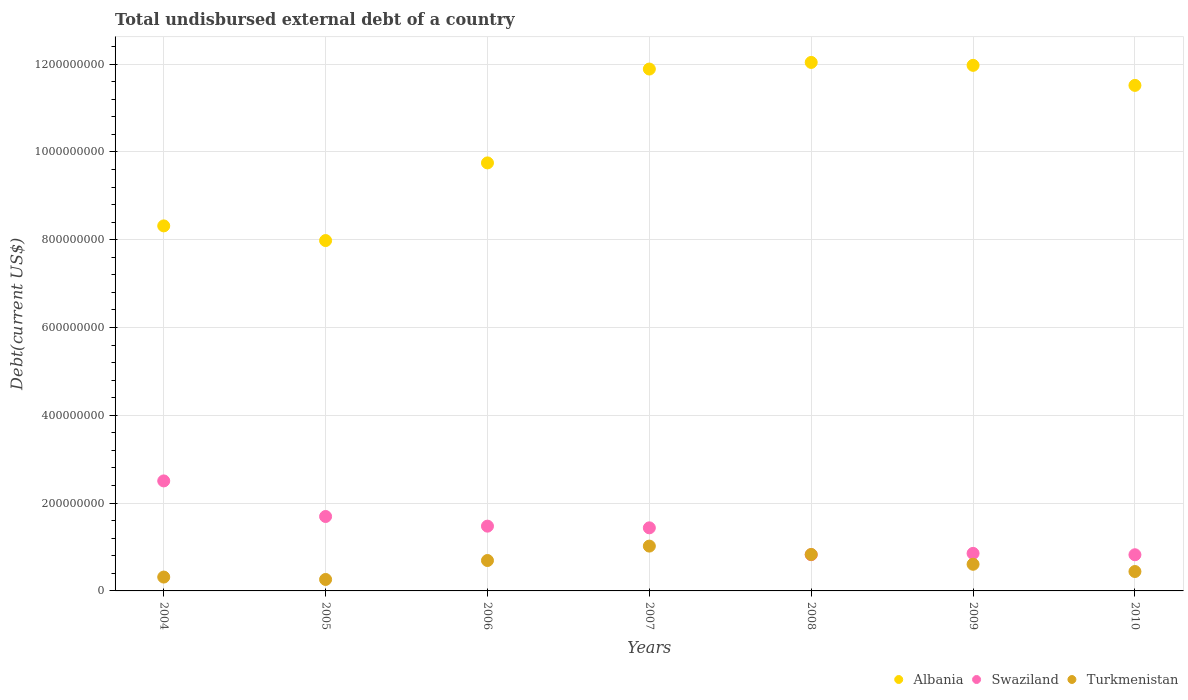How many different coloured dotlines are there?
Your response must be concise. 3. What is the total undisbursed external debt in Turkmenistan in 2008?
Your answer should be very brief. 8.30e+07. Across all years, what is the maximum total undisbursed external debt in Swaziland?
Ensure brevity in your answer.  2.51e+08. Across all years, what is the minimum total undisbursed external debt in Swaziland?
Your response must be concise. 8.24e+07. What is the total total undisbursed external debt in Albania in the graph?
Ensure brevity in your answer.  7.35e+09. What is the difference between the total undisbursed external debt in Swaziland in 2005 and that in 2007?
Make the answer very short. 2.58e+07. What is the difference between the total undisbursed external debt in Albania in 2009 and the total undisbursed external debt in Swaziland in 2010?
Offer a very short reply. 1.11e+09. What is the average total undisbursed external debt in Swaziland per year?
Your response must be concise. 1.37e+08. In the year 2009, what is the difference between the total undisbursed external debt in Albania and total undisbursed external debt in Turkmenistan?
Provide a succinct answer. 1.14e+09. What is the ratio of the total undisbursed external debt in Turkmenistan in 2008 to that in 2010?
Your response must be concise. 1.88. Is the total undisbursed external debt in Turkmenistan in 2007 less than that in 2008?
Your response must be concise. No. What is the difference between the highest and the second highest total undisbursed external debt in Turkmenistan?
Offer a terse response. 1.91e+07. What is the difference between the highest and the lowest total undisbursed external debt in Albania?
Your response must be concise. 4.06e+08. Is it the case that in every year, the sum of the total undisbursed external debt in Turkmenistan and total undisbursed external debt in Swaziland  is greater than the total undisbursed external debt in Albania?
Offer a terse response. No. Is the total undisbursed external debt in Albania strictly greater than the total undisbursed external debt in Turkmenistan over the years?
Offer a terse response. Yes. How many dotlines are there?
Give a very brief answer. 3. What is the difference between two consecutive major ticks on the Y-axis?
Offer a very short reply. 2.00e+08. Does the graph contain any zero values?
Your answer should be very brief. No. Does the graph contain grids?
Offer a terse response. Yes. Where does the legend appear in the graph?
Give a very brief answer. Bottom right. What is the title of the graph?
Give a very brief answer. Total undisbursed external debt of a country. Does "Uzbekistan" appear as one of the legend labels in the graph?
Give a very brief answer. No. What is the label or title of the X-axis?
Your answer should be compact. Years. What is the label or title of the Y-axis?
Your response must be concise. Debt(current US$). What is the Debt(current US$) of Albania in 2004?
Make the answer very short. 8.31e+08. What is the Debt(current US$) in Swaziland in 2004?
Give a very brief answer. 2.51e+08. What is the Debt(current US$) of Turkmenistan in 2004?
Your answer should be very brief. 3.16e+07. What is the Debt(current US$) in Albania in 2005?
Make the answer very short. 7.98e+08. What is the Debt(current US$) in Swaziland in 2005?
Give a very brief answer. 1.70e+08. What is the Debt(current US$) of Turkmenistan in 2005?
Offer a very short reply. 2.61e+07. What is the Debt(current US$) in Albania in 2006?
Offer a very short reply. 9.75e+08. What is the Debt(current US$) of Swaziland in 2006?
Give a very brief answer. 1.48e+08. What is the Debt(current US$) of Turkmenistan in 2006?
Make the answer very short. 6.93e+07. What is the Debt(current US$) in Albania in 2007?
Offer a terse response. 1.19e+09. What is the Debt(current US$) of Swaziland in 2007?
Your answer should be very brief. 1.44e+08. What is the Debt(current US$) of Turkmenistan in 2007?
Keep it short and to the point. 1.02e+08. What is the Debt(current US$) in Albania in 2008?
Offer a terse response. 1.20e+09. What is the Debt(current US$) in Swaziland in 2008?
Provide a succinct answer. 8.25e+07. What is the Debt(current US$) of Turkmenistan in 2008?
Provide a succinct answer. 8.30e+07. What is the Debt(current US$) of Albania in 2009?
Offer a terse response. 1.20e+09. What is the Debt(current US$) of Swaziland in 2009?
Your answer should be very brief. 8.55e+07. What is the Debt(current US$) in Turkmenistan in 2009?
Provide a succinct answer. 6.07e+07. What is the Debt(current US$) in Albania in 2010?
Ensure brevity in your answer.  1.15e+09. What is the Debt(current US$) of Swaziland in 2010?
Offer a very short reply. 8.24e+07. What is the Debt(current US$) of Turkmenistan in 2010?
Your answer should be very brief. 4.42e+07. Across all years, what is the maximum Debt(current US$) of Albania?
Your response must be concise. 1.20e+09. Across all years, what is the maximum Debt(current US$) in Swaziland?
Offer a terse response. 2.51e+08. Across all years, what is the maximum Debt(current US$) in Turkmenistan?
Offer a very short reply. 1.02e+08. Across all years, what is the minimum Debt(current US$) of Albania?
Provide a succinct answer. 7.98e+08. Across all years, what is the minimum Debt(current US$) in Swaziland?
Ensure brevity in your answer.  8.24e+07. Across all years, what is the minimum Debt(current US$) of Turkmenistan?
Offer a terse response. 2.61e+07. What is the total Debt(current US$) in Albania in the graph?
Your response must be concise. 7.35e+09. What is the total Debt(current US$) in Swaziland in the graph?
Offer a very short reply. 9.62e+08. What is the total Debt(current US$) in Turkmenistan in the graph?
Your answer should be very brief. 4.17e+08. What is the difference between the Debt(current US$) in Albania in 2004 and that in 2005?
Keep it short and to the point. 3.34e+07. What is the difference between the Debt(current US$) in Swaziland in 2004 and that in 2005?
Keep it short and to the point. 8.10e+07. What is the difference between the Debt(current US$) of Turkmenistan in 2004 and that in 2005?
Give a very brief answer. 5.43e+06. What is the difference between the Debt(current US$) in Albania in 2004 and that in 2006?
Ensure brevity in your answer.  -1.43e+08. What is the difference between the Debt(current US$) of Swaziland in 2004 and that in 2006?
Your answer should be very brief. 1.03e+08. What is the difference between the Debt(current US$) of Turkmenistan in 2004 and that in 2006?
Provide a short and direct response. -3.77e+07. What is the difference between the Debt(current US$) of Albania in 2004 and that in 2007?
Offer a terse response. -3.57e+08. What is the difference between the Debt(current US$) of Swaziland in 2004 and that in 2007?
Make the answer very short. 1.07e+08. What is the difference between the Debt(current US$) of Turkmenistan in 2004 and that in 2007?
Offer a very short reply. -7.05e+07. What is the difference between the Debt(current US$) of Albania in 2004 and that in 2008?
Offer a terse response. -3.72e+08. What is the difference between the Debt(current US$) of Swaziland in 2004 and that in 2008?
Your answer should be very brief. 1.68e+08. What is the difference between the Debt(current US$) of Turkmenistan in 2004 and that in 2008?
Your response must be concise. -5.15e+07. What is the difference between the Debt(current US$) of Albania in 2004 and that in 2009?
Provide a short and direct response. -3.66e+08. What is the difference between the Debt(current US$) in Swaziland in 2004 and that in 2009?
Your response must be concise. 1.65e+08. What is the difference between the Debt(current US$) of Turkmenistan in 2004 and that in 2009?
Give a very brief answer. -2.91e+07. What is the difference between the Debt(current US$) of Albania in 2004 and that in 2010?
Offer a terse response. -3.20e+08. What is the difference between the Debt(current US$) in Swaziland in 2004 and that in 2010?
Your answer should be compact. 1.68e+08. What is the difference between the Debt(current US$) in Turkmenistan in 2004 and that in 2010?
Make the answer very short. -1.27e+07. What is the difference between the Debt(current US$) in Albania in 2005 and that in 2006?
Provide a succinct answer. -1.77e+08. What is the difference between the Debt(current US$) in Swaziland in 2005 and that in 2006?
Ensure brevity in your answer.  2.20e+07. What is the difference between the Debt(current US$) of Turkmenistan in 2005 and that in 2006?
Give a very brief answer. -4.32e+07. What is the difference between the Debt(current US$) of Albania in 2005 and that in 2007?
Give a very brief answer. -3.91e+08. What is the difference between the Debt(current US$) of Swaziland in 2005 and that in 2007?
Keep it short and to the point. 2.58e+07. What is the difference between the Debt(current US$) of Turkmenistan in 2005 and that in 2007?
Make the answer very short. -7.60e+07. What is the difference between the Debt(current US$) of Albania in 2005 and that in 2008?
Offer a terse response. -4.06e+08. What is the difference between the Debt(current US$) of Swaziland in 2005 and that in 2008?
Your answer should be very brief. 8.70e+07. What is the difference between the Debt(current US$) in Turkmenistan in 2005 and that in 2008?
Provide a short and direct response. -5.69e+07. What is the difference between the Debt(current US$) of Albania in 2005 and that in 2009?
Offer a very short reply. -3.99e+08. What is the difference between the Debt(current US$) of Swaziland in 2005 and that in 2009?
Keep it short and to the point. 8.40e+07. What is the difference between the Debt(current US$) of Turkmenistan in 2005 and that in 2009?
Your answer should be very brief. -3.46e+07. What is the difference between the Debt(current US$) in Albania in 2005 and that in 2010?
Your answer should be compact. -3.53e+08. What is the difference between the Debt(current US$) in Swaziland in 2005 and that in 2010?
Provide a short and direct response. 8.72e+07. What is the difference between the Debt(current US$) in Turkmenistan in 2005 and that in 2010?
Your answer should be very brief. -1.81e+07. What is the difference between the Debt(current US$) in Albania in 2006 and that in 2007?
Keep it short and to the point. -2.14e+08. What is the difference between the Debt(current US$) in Swaziland in 2006 and that in 2007?
Ensure brevity in your answer.  3.86e+06. What is the difference between the Debt(current US$) in Turkmenistan in 2006 and that in 2007?
Your response must be concise. -3.28e+07. What is the difference between the Debt(current US$) of Albania in 2006 and that in 2008?
Ensure brevity in your answer.  -2.29e+08. What is the difference between the Debt(current US$) of Swaziland in 2006 and that in 2008?
Provide a succinct answer. 6.51e+07. What is the difference between the Debt(current US$) of Turkmenistan in 2006 and that in 2008?
Keep it short and to the point. -1.38e+07. What is the difference between the Debt(current US$) in Albania in 2006 and that in 2009?
Your answer should be very brief. -2.22e+08. What is the difference between the Debt(current US$) in Swaziland in 2006 and that in 2009?
Your response must be concise. 6.20e+07. What is the difference between the Debt(current US$) of Turkmenistan in 2006 and that in 2009?
Give a very brief answer. 8.58e+06. What is the difference between the Debt(current US$) in Albania in 2006 and that in 2010?
Ensure brevity in your answer.  -1.77e+08. What is the difference between the Debt(current US$) in Swaziland in 2006 and that in 2010?
Your response must be concise. 6.52e+07. What is the difference between the Debt(current US$) in Turkmenistan in 2006 and that in 2010?
Provide a short and direct response. 2.51e+07. What is the difference between the Debt(current US$) of Albania in 2007 and that in 2008?
Give a very brief answer. -1.51e+07. What is the difference between the Debt(current US$) in Swaziland in 2007 and that in 2008?
Offer a very short reply. 6.12e+07. What is the difference between the Debt(current US$) in Turkmenistan in 2007 and that in 2008?
Offer a terse response. 1.91e+07. What is the difference between the Debt(current US$) of Albania in 2007 and that in 2009?
Your response must be concise. -8.43e+06. What is the difference between the Debt(current US$) in Swaziland in 2007 and that in 2009?
Your response must be concise. 5.82e+07. What is the difference between the Debt(current US$) in Turkmenistan in 2007 and that in 2009?
Provide a short and direct response. 4.14e+07. What is the difference between the Debt(current US$) of Albania in 2007 and that in 2010?
Keep it short and to the point. 3.72e+07. What is the difference between the Debt(current US$) of Swaziland in 2007 and that in 2010?
Provide a short and direct response. 6.13e+07. What is the difference between the Debt(current US$) in Turkmenistan in 2007 and that in 2010?
Ensure brevity in your answer.  5.79e+07. What is the difference between the Debt(current US$) in Albania in 2008 and that in 2009?
Your answer should be very brief. 6.65e+06. What is the difference between the Debt(current US$) of Swaziland in 2008 and that in 2009?
Offer a very short reply. -3.02e+06. What is the difference between the Debt(current US$) of Turkmenistan in 2008 and that in 2009?
Provide a short and direct response. 2.23e+07. What is the difference between the Debt(current US$) of Albania in 2008 and that in 2010?
Your answer should be very brief. 5.23e+07. What is the difference between the Debt(current US$) in Swaziland in 2008 and that in 2010?
Keep it short and to the point. 1.10e+05. What is the difference between the Debt(current US$) of Turkmenistan in 2008 and that in 2010?
Your answer should be very brief. 3.88e+07. What is the difference between the Debt(current US$) of Albania in 2009 and that in 2010?
Give a very brief answer. 4.56e+07. What is the difference between the Debt(current US$) of Swaziland in 2009 and that in 2010?
Ensure brevity in your answer.  3.13e+06. What is the difference between the Debt(current US$) of Turkmenistan in 2009 and that in 2010?
Give a very brief answer. 1.65e+07. What is the difference between the Debt(current US$) of Albania in 2004 and the Debt(current US$) of Swaziland in 2005?
Make the answer very short. 6.62e+08. What is the difference between the Debt(current US$) in Albania in 2004 and the Debt(current US$) in Turkmenistan in 2005?
Offer a very short reply. 8.05e+08. What is the difference between the Debt(current US$) of Swaziland in 2004 and the Debt(current US$) of Turkmenistan in 2005?
Keep it short and to the point. 2.24e+08. What is the difference between the Debt(current US$) of Albania in 2004 and the Debt(current US$) of Swaziland in 2006?
Make the answer very short. 6.84e+08. What is the difference between the Debt(current US$) of Albania in 2004 and the Debt(current US$) of Turkmenistan in 2006?
Offer a terse response. 7.62e+08. What is the difference between the Debt(current US$) in Swaziland in 2004 and the Debt(current US$) in Turkmenistan in 2006?
Your answer should be very brief. 1.81e+08. What is the difference between the Debt(current US$) in Albania in 2004 and the Debt(current US$) in Swaziland in 2007?
Keep it short and to the point. 6.88e+08. What is the difference between the Debt(current US$) of Albania in 2004 and the Debt(current US$) of Turkmenistan in 2007?
Ensure brevity in your answer.  7.29e+08. What is the difference between the Debt(current US$) of Swaziland in 2004 and the Debt(current US$) of Turkmenistan in 2007?
Keep it short and to the point. 1.48e+08. What is the difference between the Debt(current US$) of Albania in 2004 and the Debt(current US$) of Swaziland in 2008?
Provide a short and direct response. 7.49e+08. What is the difference between the Debt(current US$) in Albania in 2004 and the Debt(current US$) in Turkmenistan in 2008?
Make the answer very short. 7.48e+08. What is the difference between the Debt(current US$) in Swaziland in 2004 and the Debt(current US$) in Turkmenistan in 2008?
Provide a succinct answer. 1.68e+08. What is the difference between the Debt(current US$) of Albania in 2004 and the Debt(current US$) of Swaziland in 2009?
Provide a short and direct response. 7.46e+08. What is the difference between the Debt(current US$) in Albania in 2004 and the Debt(current US$) in Turkmenistan in 2009?
Your response must be concise. 7.71e+08. What is the difference between the Debt(current US$) in Swaziland in 2004 and the Debt(current US$) in Turkmenistan in 2009?
Offer a terse response. 1.90e+08. What is the difference between the Debt(current US$) in Albania in 2004 and the Debt(current US$) in Swaziland in 2010?
Make the answer very short. 7.49e+08. What is the difference between the Debt(current US$) of Albania in 2004 and the Debt(current US$) of Turkmenistan in 2010?
Keep it short and to the point. 7.87e+08. What is the difference between the Debt(current US$) of Swaziland in 2004 and the Debt(current US$) of Turkmenistan in 2010?
Offer a very short reply. 2.06e+08. What is the difference between the Debt(current US$) in Albania in 2005 and the Debt(current US$) in Swaziland in 2006?
Your answer should be compact. 6.51e+08. What is the difference between the Debt(current US$) of Albania in 2005 and the Debt(current US$) of Turkmenistan in 2006?
Give a very brief answer. 7.29e+08. What is the difference between the Debt(current US$) of Swaziland in 2005 and the Debt(current US$) of Turkmenistan in 2006?
Your answer should be very brief. 1.00e+08. What is the difference between the Debt(current US$) in Albania in 2005 and the Debt(current US$) in Swaziland in 2007?
Ensure brevity in your answer.  6.54e+08. What is the difference between the Debt(current US$) of Albania in 2005 and the Debt(current US$) of Turkmenistan in 2007?
Keep it short and to the point. 6.96e+08. What is the difference between the Debt(current US$) of Swaziland in 2005 and the Debt(current US$) of Turkmenistan in 2007?
Your response must be concise. 6.74e+07. What is the difference between the Debt(current US$) in Albania in 2005 and the Debt(current US$) in Swaziland in 2008?
Your response must be concise. 7.16e+08. What is the difference between the Debt(current US$) in Albania in 2005 and the Debt(current US$) in Turkmenistan in 2008?
Your response must be concise. 7.15e+08. What is the difference between the Debt(current US$) of Swaziland in 2005 and the Debt(current US$) of Turkmenistan in 2008?
Give a very brief answer. 8.65e+07. What is the difference between the Debt(current US$) in Albania in 2005 and the Debt(current US$) in Swaziland in 2009?
Your answer should be very brief. 7.13e+08. What is the difference between the Debt(current US$) of Albania in 2005 and the Debt(current US$) of Turkmenistan in 2009?
Offer a terse response. 7.37e+08. What is the difference between the Debt(current US$) in Swaziland in 2005 and the Debt(current US$) in Turkmenistan in 2009?
Make the answer very short. 1.09e+08. What is the difference between the Debt(current US$) in Albania in 2005 and the Debt(current US$) in Swaziland in 2010?
Keep it short and to the point. 7.16e+08. What is the difference between the Debt(current US$) in Albania in 2005 and the Debt(current US$) in Turkmenistan in 2010?
Offer a very short reply. 7.54e+08. What is the difference between the Debt(current US$) of Swaziland in 2005 and the Debt(current US$) of Turkmenistan in 2010?
Your response must be concise. 1.25e+08. What is the difference between the Debt(current US$) in Albania in 2006 and the Debt(current US$) in Swaziland in 2007?
Your answer should be very brief. 8.31e+08. What is the difference between the Debt(current US$) in Albania in 2006 and the Debt(current US$) in Turkmenistan in 2007?
Your answer should be very brief. 8.73e+08. What is the difference between the Debt(current US$) in Swaziland in 2006 and the Debt(current US$) in Turkmenistan in 2007?
Your answer should be very brief. 4.54e+07. What is the difference between the Debt(current US$) of Albania in 2006 and the Debt(current US$) of Swaziland in 2008?
Make the answer very short. 8.92e+08. What is the difference between the Debt(current US$) of Albania in 2006 and the Debt(current US$) of Turkmenistan in 2008?
Your response must be concise. 8.92e+08. What is the difference between the Debt(current US$) of Swaziland in 2006 and the Debt(current US$) of Turkmenistan in 2008?
Your answer should be very brief. 6.45e+07. What is the difference between the Debt(current US$) of Albania in 2006 and the Debt(current US$) of Swaziland in 2009?
Your response must be concise. 8.89e+08. What is the difference between the Debt(current US$) in Albania in 2006 and the Debt(current US$) in Turkmenistan in 2009?
Offer a very short reply. 9.14e+08. What is the difference between the Debt(current US$) in Swaziland in 2006 and the Debt(current US$) in Turkmenistan in 2009?
Offer a terse response. 8.69e+07. What is the difference between the Debt(current US$) in Albania in 2006 and the Debt(current US$) in Swaziland in 2010?
Your answer should be very brief. 8.93e+08. What is the difference between the Debt(current US$) of Albania in 2006 and the Debt(current US$) of Turkmenistan in 2010?
Give a very brief answer. 9.31e+08. What is the difference between the Debt(current US$) in Swaziland in 2006 and the Debt(current US$) in Turkmenistan in 2010?
Offer a terse response. 1.03e+08. What is the difference between the Debt(current US$) of Albania in 2007 and the Debt(current US$) of Swaziland in 2008?
Your response must be concise. 1.11e+09. What is the difference between the Debt(current US$) in Albania in 2007 and the Debt(current US$) in Turkmenistan in 2008?
Provide a succinct answer. 1.11e+09. What is the difference between the Debt(current US$) of Swaziland in 2007 and the Debt(current US$) of Turkmenistan in 2008?
Provide a short and direct response. 6.07e+07. What is the difference between the Debt(current US$) in Albania in 2007 and the Debt(current US$) in Swaziland in 2009?
Keep it short and to the point. 1.10e+09. What is the difference between the Debt(current US$) of Albania in 2007 and the Debt(current US$) of Turkmenistan in 2009?
Your answer should be compact. 1.13e+09. What is the difference between the Debt(current US$) in Swaziland in 2007 and the Debt(current US$) in Turkmenistan in 2009?
Offer a very short reply. 8.30e+07. What is the difference between the Debt(current US$) in Albania in 2007 and the Debt(current US$) in Swaziland in 2010?
Provide a succinct answer. 1.11e+09. What is the difference between the Debt(current US$) of Albania in 2007 and the Debt(current US$) of Turkmenistan in 2010?
Your answer should be compact. 1.14e+09. What is the difference between the Debt(current US$) of Swaziland in 2007 and the Debt(current US$) of Turkmenistan in 2010?
Your response must be concise. 9.95e+07. What is the difference between the Debt(current US$) of Albania in 2008 and the Debt(current US$) of Swaziland in 2009?
Your answer should be very brief. 1.12e+09. What is the difference between the Debt(current US$) of Albania in 2008 and the Debt(current US$) of Turkmenistan in 2009?
Provide a succinct answer. 1.14e+09. What is the difference between the Debt(current US$) of Swaziland in 2008 and the Debt(current US$) of Turkmenistan in 2009?
Your response must be concise. 2.18e+07. What is the difference between the Debt(current US$) of Albania in 2008 and the Debt(current US$) of Swaziland in 2010?
Your response must be concise. 1.12e+09. What is the difference between the Debt(current US$) in Albania in 2008 and the Debt(current US$) in Turkmenistan in 2010?
Ensure brevity in your answer.  1.16e+09. What is the difference between the Debt(current US$) in Swaziland in 2008 and the Debt(current US$) in Turkmenistan in 2010?
Your answer should be very brief. 3.83e+07. What is the difference between the Debt(current US$) of Albania in 2009 and the Debt(current US$) of Swaziland in 2010?
Offer a terse response. 1.11e+09. What is the difference between the Debt(current US$) of Albania in 2009 and the Debt(current US$) of Turkmenistan in 2010?
Make the answer very short. 1.15e+09. What is the difference between the Debt(current US$) of Swaziland in 2009 and the Debt(current US$) of Turkmenistan in 2010?
Your answer should be very brief. 4.13e+07. What is the average Debt(current US$) in Albania per year?
Make the answer very short. 1.05e+09. What is the average Debt(current US$) in Swaziland per year?
Your response must be concise. 1.37e+08. What is the average Debt(current US$) of Turkmenistan per year?
Your answer should be compact. 5.96e+07. In the year 2004, what is the difference between the Debt(current US$) in Albania and Debt(current US$) in Swaziland?
Your response must be concise. 5.81e+08. In the year 2004, what is the difference between the Debt(current US$) of Albania and Debt(current US$) of Turkmenistan?
Give a very brief answer. 8.00e+08. In the year 2004, what is the difference between the Debt(current US$) of Swaziland and Debt(current US$) of Turkmenistan?
Keep it short and to the point. 2.19e+08. In the year 2005, what is the difference between the Debt(current US$) in Albania and Debt(current US$) in Swaziland?
Keep it short and to the point. 6.29e+08. In the year 2005, what is the difference between the Debt(current US$) of Albania and Debt(current US$) of Turkmenistan?
Ensure brevity in your answer.  7.72e+08. In the year 2005, what is the difference between the Debt(current US$) in Swaziland and Debt(current US$) in Turkmenistan?
Offer a terse response. 1.43e+08. In the year 2006, what is the difference between the Debt(current US$) of Albania and Debt(current US$) of Swaziland?
Make the answer very short. 8.27e+08. In the year 2006, what is the difference between the Debt(current US$) in Albania and Debt(current US$) in Turkmenistan?
Provide a succinct answer. 9.06e+08. In the year 2006, what is the difference between the Debt(current US$) of Swaziland and Debt(current US$) of Turkmenistan?
Give a very brief answer. 7.83e+07. In the year 2007, what is the difference between the Debt(current US$) of Albania and Debt(current US$) of Swaziland?
Provide a succinct answer. 1.05e+09. In the year 2007, what is the difference between the Debt(current US$) of Albania and Debt(current US$) of Turkmenistan?
Your answer should be very brief. 1.09e+09. In the year 2007, what is the difference between the Debt(current US$) of Swaziland and Debt(current US$) of Turkmenistan?
Your answer should be compact. 4.16e+07. In the year 2008, what is the difference between the Debt(current US$) of Albania and Debt(current US$) of Swaziland?
Ensure brevity in your answer.  1.12e+09. In the year 2008, what is the difference between the Debt(current US$) in Albania and Debt(current US$) in Turkmenistan?
Ensure brevity in your answer.  1.12e+09. In the year 2008, what is the difference between the Debt(current US$) in Swaziland and Debt(current US$) in Turkmenistan?
Give a very brief answer. -5.38e+05. In the year 2009, what is the difference between the Debt(current US$) of Albania and Debt(current US$) of Swaziland?
Keep it short and to the point. 1.11e+09. In the year 2009, what is the difference between the Debt(current US$) in Albania and Debt(current US$) in Turkmenistan?
Provide a succinct answer. 1.14e+09. In the year 2009, what is the difference between the Debt(current US$) in Swaziland and Debt(current US$) in Turkmenistan?
Make the answer very short. 2.48e+07. In the year 2010, what is the difference between the Debt(current US$) of Albania and Debt(current US$) of Swaziland?
Ensure brevity in your answer.  1.07e+09. In the year 2010, what is the difference between the Debt(current US$) in Albania and Debt(current US$) in Turkmenistan?
Give a very brief answer. 1.11e+09. In the year 2010, what is the difference between the Debt(current US$) of Swaziland and Debt(current US$) of Turkmenistan?
Your answer should be very brief. 3.82e+07. What is the ratio of the Debt(current US$) of Albania in 2004 to that in 2005?
Offer a terse response. 1.04. What is the ratio of the Debt(current US$) of Swaziland in 2004 to that in 2005?
Give a very brief answer. 1.48. What is the ratio of the Debt(current US$) in Turkmenistan in 2004 to that in 2005?
Your answer should be compact. 1.21. What is the ratio of the Debt(current US$) of Albania in 2004 to that in 2006?
Offer a very short reply. 0.85. What is the ratio of the Debt(current US$) in Swaziland in 2004 to that in 2006?
Your response must be concise. 1.7. What is the ratio of the Debt(current US$) in Turkmenistan in 2004 to that in 2006?
Offer a terse response. 0.46. What is the ratio of the Debt(current US$) in Albania in 2004 to that in 2007?
Make the answer very short. 0.7. What is the ratio of the Debt(current US$) in Swaziland in 2004 to that in 2007?
Provide a short and direct response. 1.74. What is the ratio of the Debt(current US$) in Turkmenistan in 2004 to that in 2007?
Your answer should be compact. 0.31. What is the ratio of the Debt(current US$) of Albania in 2004 to that in 2008?
Provide a succinct answer. 0.69. What is the ratio of the Debt(current US$) of Swaziland in 2004 to that in 2008?
Give a very brief answer. 3.04. What is the ratio of the Debt(current US$) of Turkmenistan in 2004 to that in 2008?
Make the answer very short. 0.38. What is the ratio of the Debt(current US$) in Albania in 2004 to that in 2009?
Your answer should be compact. 0.69. What is the ratio of the Debt(current US$) in Swaziland in 2004 to that in 2009?
Ensure brevity in your answer.  2.93. What is the ratio of the Debt(current US$) of Turkmenistan in 2004 to that in 2009?
Your answer should be compact. 0.52. What is the ratio of the Debt(current US$) in Albania in 2004 to that in 2010?
Provide a succinct answer. 0.72. What is the ratio of the Debt(current US$) of Swaziland in 2004 to that in 2010?
Ensure brevity in your answer.  3.04. What is the ratio of the Debt(current US$) in Turkmenistan in 2004 to that in 2010?
Your answer should be very brief. 0.71. What is the ratio of the Debt(current US$) in Albania in 2005 to that in 2006?
Your response must be concise. 0.82. What is the ratio of the Debt(current US$) of Swaziland in 2005 to that in 2006?
Provide a succinct answer. 1.15. What is the ratio of the Debt(current US$) of Turkmenistan in 2005 to that in 2006?
Provide a short and direct response. 0.38. What is the ratio of the Debt(current US$) in Albania in 2005 to that in 2007?
Offer a terse response. 0.67. What is the ratio of the Debt(current US$) in Swaziland in 2005 to that in 2007?
Offer a very short reply. 1.18. What is the ratio of the Debt(current US$) in Turkmenistan in 2005 to that in 2007?
Your answer should be very brief. 0.26. What is the ratio of the Debt(current US$) in Albania in 2005 to that in 2008?
Offer a very short reply. 0.66. What is the ratio of the Debt(current US$) in Swaziland in 2005 to that in 2008?
Provide a short and direct response. 2.06. What is the ratio of the Debt(current US$) of Turkmenistan in 2005 to that in 2008?
Provide a short and direct response. 0.31. What is the ratio of the Debt(current US$) in Albania in 2005 to that in 2009?
Provide a short and direct response. 0.67. What is the ratio of the Debt(current US$) of Swaziland in 2005 to that in 2009?
Provide a short and direct response. 1.98. What is the ratio of the Debt(current US$) of Turkmenistan in 2005 to that in 2009?
Ensure brevity in your answer.  0.43. What is the ratio of the Debt(current US$) in Albania in 2005 to that in 2010?
Provide a succinct answer. 0.69. What is the ratio of the Debt(current US$) in Swaziland in 2005 to that in 2010?
Your response must be concise. 2.06. What is the ratio of the Debt(current US$) in Turkmenistan in 2005 to that in 2010?
Your answer should be compact. 0.59. What is the ratio of the Debt(current US$) in Albania in 2006 to that in 2007?
Offer a terse response. 0.82. What is the ratio of the Debt(current US$) in Swaziland in 2006 to that in 2007?
Offer a terse response. 1.03. What is the ratio of the Debt(current US$) in Turkmenistan in 2006 to that in 2007?
Offer a very short reply. 0.68. What is the ratio of the Debt(current US$) of Albania in 2006 to that in 2008?
Your response must be concise. 0.81. What is the ratio of the Debt(current US$) in Swaziland in 2006 to that in 2008?
Give a very brief answer. 1.79. What is the ratio of the Debt(current US$) in Turkmenistan in 2006 to that in 2008?
Your answer should be very brief. 0.83. What is the ratio of the Debt(current US$) of Albania in 2006 to that in 2009?
Your answer should be compact. 0.81. What is the ratio of the Debt(current US$) in Swaziland in 2006 to that in 2009?
Give a very brief answer. 1.73. What is the ratio of the Debt(current US$) in Turkmenistan in 2006 to that in 2009?
Your response must be concise. 1.14. What is the ratio of the Debt(current US$) in Albania in 2006 to that in 2010?
Your answer should be very brief. 0.85. What is the ratio of the Debt(current US$) in Swaziland in 2006 to that in 2010?
Provide a succinct answer. 1.79. What is the ratio of the Debt(current US$) in Turkmenistan in 2006 to that in 2010?
Provide a succinct answer. 1.57. What is the ratio of the Debt(current US$) in Albania in 2007 to that in 2008?
Provide a short and direct response. 0.99. What is the ratio of the Debt(current US$) of Swaziland in 2007 to that in 2008?
Provide a short and direct response. 1.74. What is the ratio of the Debt(current US$) of Turkmenistan in 2007 to that in 2008?
Provide a succinct answer. 1.23. What is the ratio of the Debt(current US$) in Swaziland in 2007 to that in 2009?
Your answer should be compact. 1.68. What is the ratio of the Debt(current US$) in Turkmenistan in 2007 to that in 2009?
Keep it short and to the point. 1.68. What is the ratio of the Debt(current US$) of Albania in 2007 to that in 2010?
Keep it short and to the point. 1.03. What is the ratio of the Debt(current US$) of Swaziland in 2007 to that in 2010?
Ensure brevity in your answer.  1.74. What is the ratio of the Debt(current US$) of Turkmenistan in 2007 to that in 2010?
Your response must be concise. 2.31. What is the ratio of the Debt(current US$) in Albania in 2008 to that in 2009?
Your answer should be compact. 1.01. What is the ratio of the Debt(current US$) in Swaziland in 2008 to that in 2009?
Provide a succinct answer. 0.96. What is the ratio of the Debt(current US$) in Turkmenistan in 2008 to that in 2009?
Your response must be concise. 1.37. What is the ratio of the Debt(current US$) in Albania in 2008 to that in 2010?
Offer a very short reply. 1.05. What is the ratio of the Debt(current US$) of Turkmenistan in 2008 to that in 2010?
Your answer should be compact. 1.88. What is the ratio of the Debt(current US$) of Albania in 2009 to that in 2010?
Offer a terse response. 1.04. What is the ratio of the Debt(current US$) in Swaziland in 2009 to that in 2010?
Give a very brief answer. 1.04. What is the ratio of the Debt(current US$) in Turkmenistan in 2009 to that in 2010?
Keep it short and to the point. 1.37. What is the difference between the highest and the second highest Debt(current US$) of Albania?
Your response must be concise. 6.65e+06. What is the difference between the highest and the second highest Debt(current US$) in Swaziland?
Give a very brief answer. 8.10e+07. What is the difference between the highest and the second highest Debt(current US$) of Turkmenistan?
Your answer should be compact. 1.91e+07. What is the difference between the highest and the lowest Debt(current US$) in Albania?
Your answer should be very brief. 4.06e+08. What is the difference between the highest and the lowest Debt(current US$) of Swaziland?
Offer a very short reply. 1.68e+08. What is the difference between the highest and the lowest Debt(current US$) of Turkmenistan?
Your answer should be compact. 7.60e+07. 